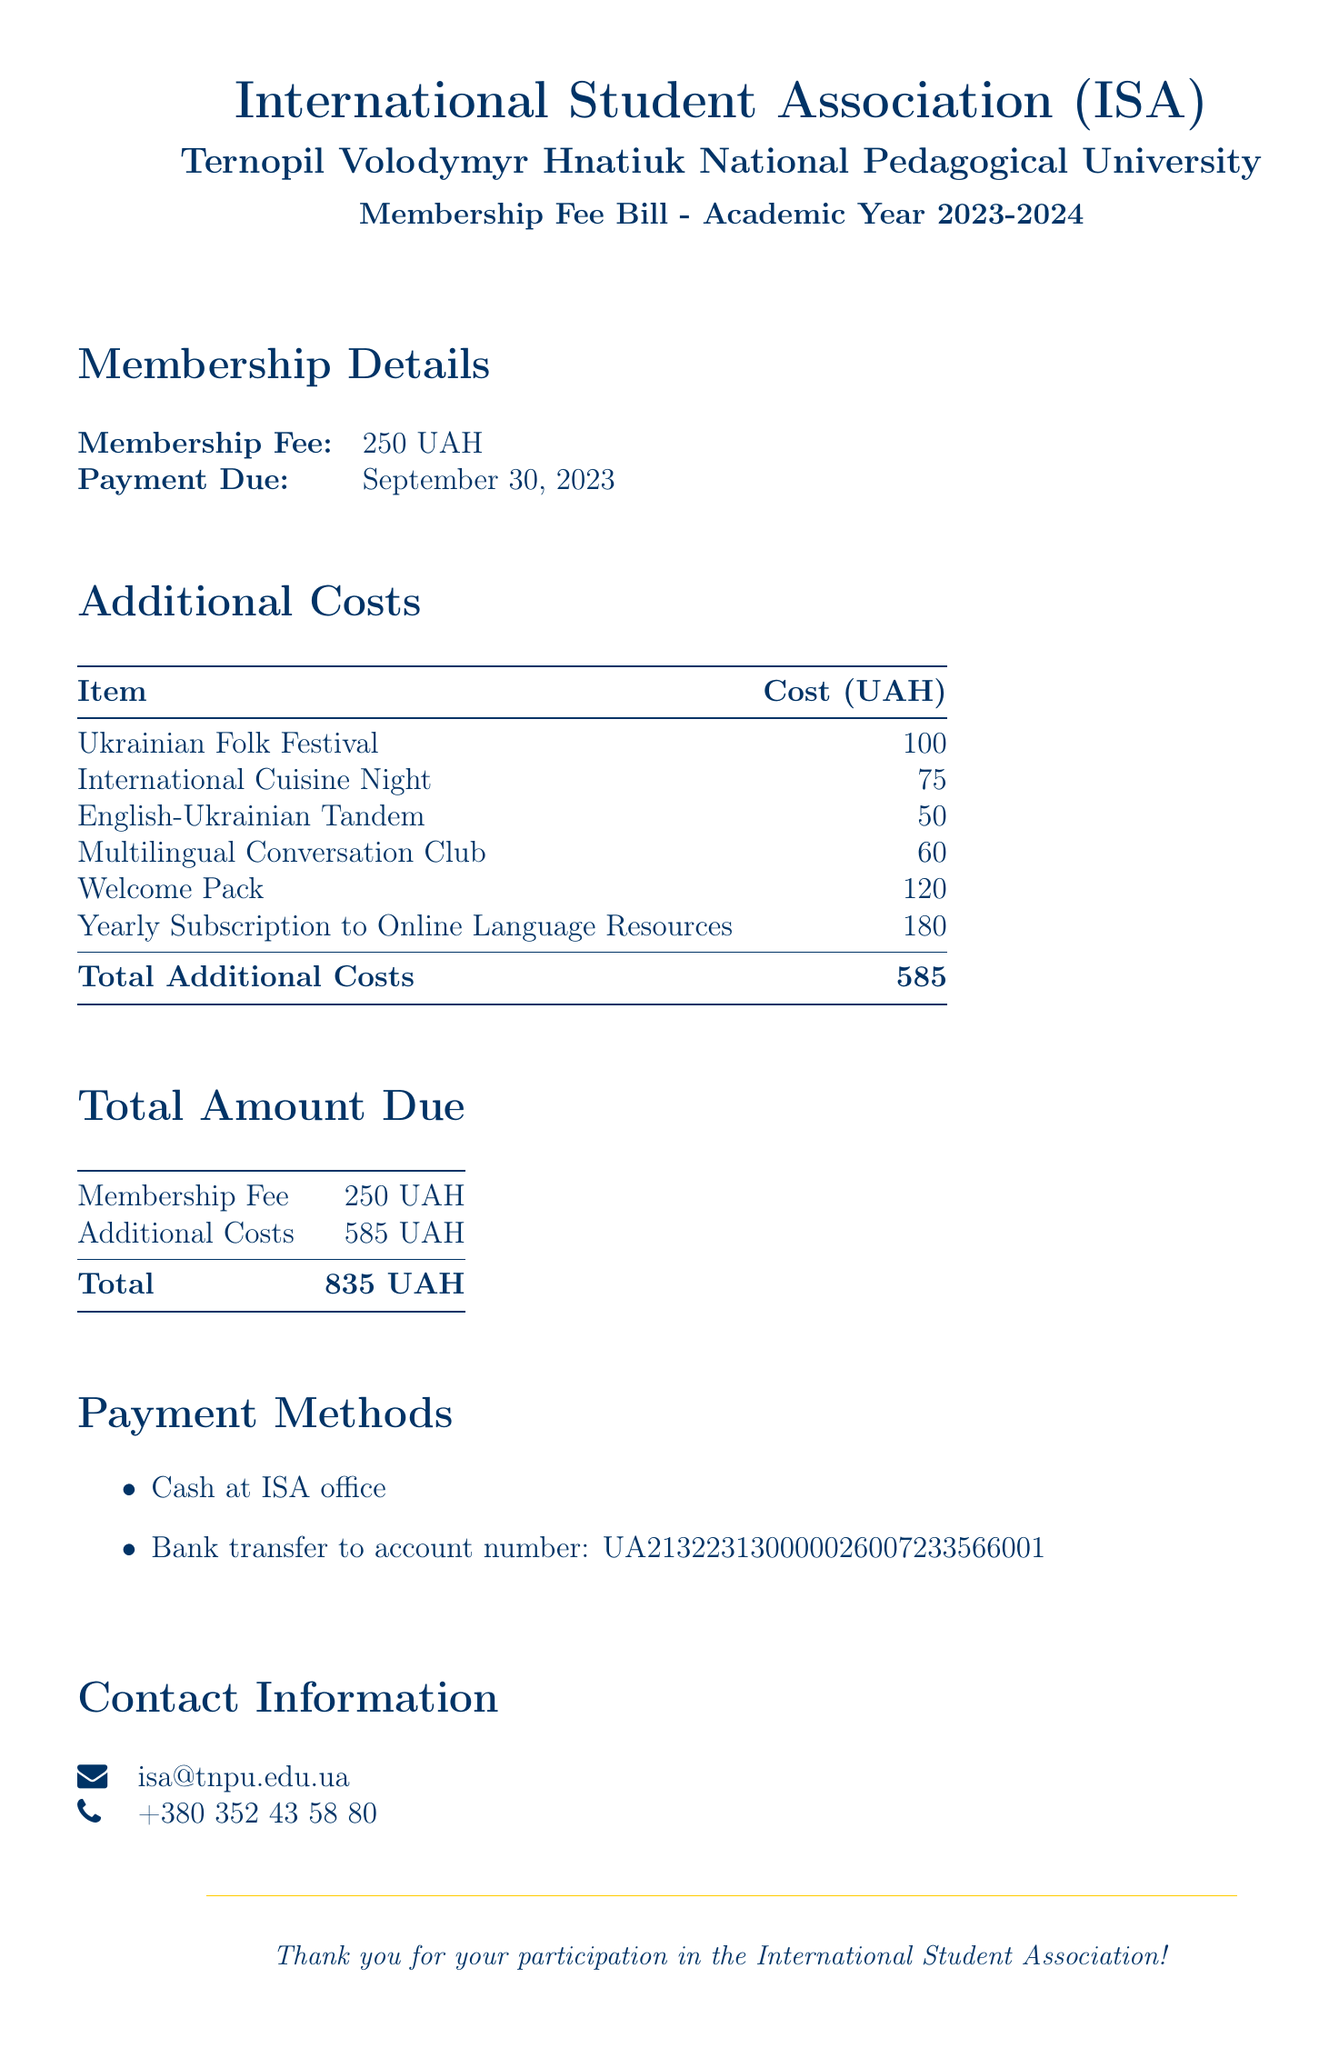what is the membership fee? The membership fee is explicitly stated in the document under membership details.
Answer: 250 UAH when is the payment due? The document specifies the due date for payment.
Answer: September 30, 2023 how much does the Ukrainian Folk Festival cost? The cost of the Ukrainian Folk Festival is listed in the additional costs section.
Answer: 100 UAH what is the total amount due? The total amount due is the sum of the membership fee and additional costs presented in the total amount due section.
Answer: 835 UAH what is included in the welcome pack cost? The document doesn't specify the contents of the welcome pack, but it lists its cost.
Answer: 120 UAH how much does the Yearly Subscription to Online Language Resources cost? The amount for the subscription is mentioned in the additional costs table.
Answer: 180 UAH what are the payment methods listed in the document? The document outlines the payment methods for the membership fee.
Answer: Cash at ISA office, Bank transfer how many cultural events are listed in the document? The document lists several cultural events in the additional costs section.
Answer: 2 events is the International Student Association part of Ternopil Volodymyr Hnatiuk National Pedagogical University? The document indicates the affiliation of the International Student Association.
Answer: Yes 